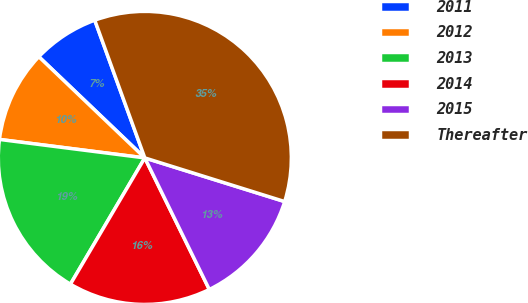Convert chart to OTSL. <chart><loc_0><loc_0><loc_500><loc_500><pie_chart><fcel>2011<fcel>2012<fcel>2013<fcel>2014<fcel>2015<fcel>Thereafter<nl><fcel>7.32%<fcel>10.12%<fcel>18.54%<fcel>15.73%<fcel>12.93%<fcel>35.37%<nl></chart> 